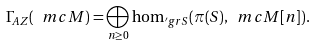Convert formula to latex. <formula><loc_0><loc_0><loc_500><loc_500>\Gamma _ { A Z } ( \ m c { M } ) = \bigoplus _ { n \geq 0 } \hom _ { \rq g r S } ( \pi ( S ) , \ m c { M } [ n ] ) .</formula> 